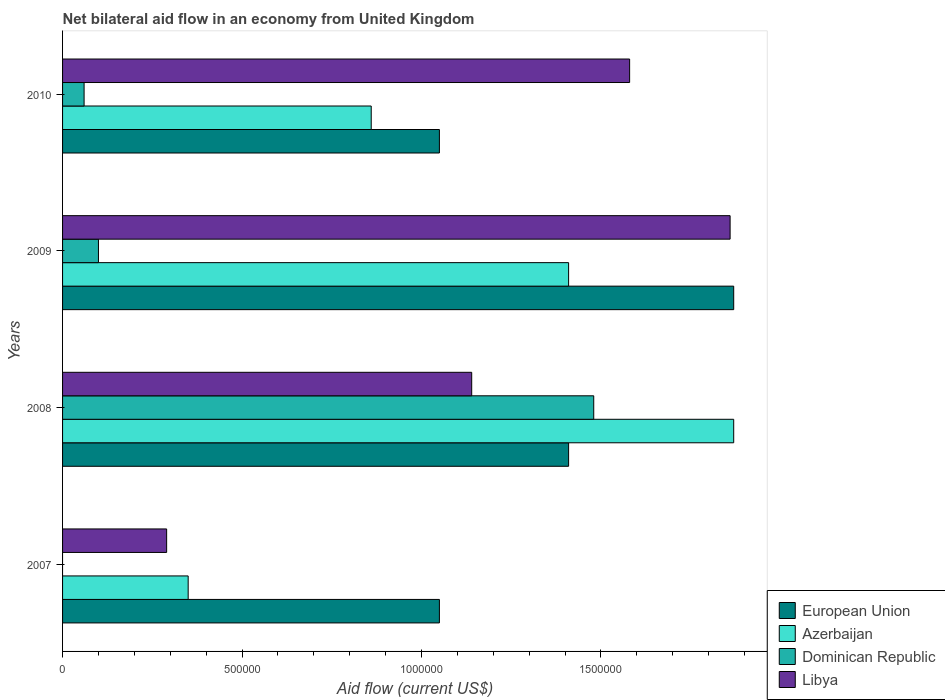How many different coloured bars are there?
Offer a very short reply. 4. Are the number of bars per tick equal to the number of legend labels?
Offer a terse response. No. Are the number of bars on each tick of the Y-axis equal?
Make the answer very short. No. How many bars are there on the 1st tick from the top?
Make the answer very short. 4. In how many cases, is the number of bars for a given year not equal to the number of legend labels?
Keep it short and to the point. 1. What is the net bilateral aid flow in European Union in 2008?
Make the answer very short. 1.41e+06. Across all years, what is the maximum net bilateral aid flow in Azerbaijan?
Keep it short and to the point. 1.87e+06. Across all years, what is the minimum net bilateral aid flow in European Union?
Offer a terse response. 1.05e+06. What is the total net bilateral aid flow in Dominican Republic in the graph?
Your answer should be very brief. 1.64e+06. What is the difference between the net bilateral aid flow in Azerbaijan in 2007 and that in 2010?
Keep it short and to the point. -5.10e+05. What is the difference between the net bilateral aid flow in European Union in 2010 and the net bilateral aid flow in Azerbaijan in 2008?
Your answer should be very brief. -8.20e+05. What is the average net bilateral aid flow in Dominican Republic per year?
Your answer should be compact. 4.10e+05. In the year 2009, what is the difference between the net bilateral aid flow in Libya and net bilateral aid flow in Azerbaijan?
Offer a very short reply. 4.50e+05. What is the ratio of the net bilateral aid flow in Azerbaijan in 2009 to that in 2010?
Your answer should be compact. 1.64. What is the difference between the highest and the lowest net bilateral aid flow in Dominican Republic?
Your answer should be very brief. 1.48e+06. In how many years, is the net bilateral aid flow in European Union greater than the average net bilateral aid flow in European Union taken over all years?
Provide a short and direct response. 2. Is it the case that in every year, the sum of the net bilateral aid flow in Azerbaijan and net bilateral aid flow in European Union is greater than the sum of net bilateral aid flow in Dominican Republic and net bilateral aid flow in Libya?
Your answer should be compact. No. Is it the case that in every year, the sum of the net bilateral aid flow in European Union and net bilateral aid flow in Dominican Republic is greater than the net bilateral aid flow in Azerbaijan?
Your response must be concise. Yes. How many legend labels are there?
Your answer should be very brief. 4. How are the legend labels stacked?
Ensure brevity in your answer.  Vertical. What is the title of the graph?
Provide a succinct answer. Net bilateral aid flow in an economy from United Kingdom. What is the label or title of the X-axis?
Offer a very short reply. Aid flow (current US$). What is the label or title of the Y-axis?
Your response must be concise. Years. What is the Aid flow (current US$) of European Union in 2007?
Keep it short and to the point. 1.05e+06. What is the Aid flow (current US$) of Azerbaijan in 2007?
Give a very brief answer. 3.50e+05. What is the Aid flow (current US$) of European Union in 2008?
Keep it short and to the point. 1.41e+06. What is the Aid flow (current US$) of Azerbaijan in 2008?
Provide a succinct answer. 1.87e+06. What is the Aid flow (current US$) in Dominican Republic in 2008?
Your answer should be compact. 1.48e+06. What is the Aid flow (current US$) in Libya in 2008?
Provide a succinct answer. 1.14e+06. What is the Aid flow (current US$) of European Union in 2009?
Ensure brevity in your answer.  1.87e+06. What is the Aid flow (current US$) in Azerbaijan in 2009?
Keep it short and to the point. 1.41e+06. What is the Aid flow (current US$) of Dominican Republic in 2009?
Provide a short and direct response. 1.00e+05. What is the Aid flow (current US$) in Libya in 2009?
Ensure brevity in your answer.  1.86e+06. What is the Aid flow (current US$) of European Union in 2010?
Offer a terse response. 1.05e+06. What is the Aid flow (current US$) in Azerbaijan in 2010?
Provide a succinct answer. 8.60e+05. What is the Aid flow (current US$) of Libya in 2010?
Provide a short and direct response. 1.58e+06. Across all years, what is the maximum Aid flow (current US$) in European Union?
Offer a very short reply. 1.87e+06. Across all years, what is the maximum Aid flow (current US$) of Azerbaijan?
Provide a succinct answer. 1.87e+06. Across all years, what is the maximum Aid flow (current US$) in Dominican Republic?
Make the answer very short. 1.48e+06. Across all years, what is the maximum Aid flow (current US$) of Libya?
Make the answer very short. 1.86e+06. Across all years, what is the minimum Aid flow (current US$) of European Union?
Ensure brevity in your answer.  1.05e+06. Across all years, what is the minimum Aid flow (current US$) in Azerbaijan?
Your answer should be compact. 3.50e+05. Across all years, what is the minimum Aid flow (current US$) in Dominican Republic?
Make the answer very short. 0. What is the total Aid flow (current US$) of European Union in the graph?
Your answer should be very brief. 5.38e+06. What is the total Aid flow (current US$) of Azerbaijan in the graph?
Ensure brevity in your answer.  4.49e+06. What is the total Aid flow (current US$) in Dominican Republic in the graph?
Offer a terse response. 1.64e+06. What is the total Aid flow (current US$) in Libya in the graph?
Ensure brevity in your answer.  4.87e+06. What is the difference between the Aid flow (current US$) in European Union in 2007 and that in 2008?
Your answer should be compact. -3.60e+05. What is the difference between the Aid flow (current US$) of Azerbaijan in 2007 and that in 2008?
Provide a short and direct response. -1.52e+06. What is the difference between the Aid flow (current US$) in Libya in 2007 and that in 2008?
Offer a very short reply. -8.50e+05. What is the difference between the Aid flow (current US$) of European Union in 2007 and that in 2009?
Your response must be concise. -8.20e+05. What is the difference between the Aid flow (current US$) in Azerbaijan in 2007 and that in 2009?
Your answer should be compact. -1.06e+06. What is the difference between the Aid flow (current US$) in Libya in 2007 and that in 2009?
Offer a very short reply. -1.57e+06. What is the difference between the Aid flow (current US$) in European Union in 2007 and that in 2010?
Your answer should be very brief. 0. What is the difference between the Aid flow (current US$) in Azerbaijan in 2007 and that in 2010?
Your answer should be compact. -5.10e+05. What is the difference between the Aid flow (current US$) of Libya in 2007 and that in 2010?
Provide a succinct answer. -1.29e+06. What is the difference between the Aid flow (current US$) in European Union in 2008 and that in 2009?
Provide a succinct answer. -4.60e+05. What is the difference between the Aid flow (current US$) of Azerbaijan in 2008 and that in 2009?
Offer a very short reply. 4.60e+05. What is the difference between the Aid flow (current US$) in Dominican Republic in 2008 and that in 2009?
Your response must be concise. 1.38e+06. What is the difference between the Aid flow (current US$) in Libya in 2008 and that in 2009?
Your answer should be compact. -7.20e+05. What is the difference between the Aid flow (current US$) in European Union in 2008 and that in 2010?
Make the answer very short. 3.60e+05. What is the difference between the Aid flow (current US$) of Azerbaijan in 2008 and that in 2010?
Your response must be concise. 1.01e+06. What is the difference between the Aid flow (current US$) in Dominican Republic in 2008 and that in 2010?
Offer a very short reply. 1.42e+06. What is the difference between the Aid flow (current US$) in Libya in 2008 and that in 2010?
Offer a terse response. -4.40e+05. What is the difference between the Aid flow (current US$) in European Union in 2009 and that in 2010?
Provide a succinct answer. 8.20e+05. What is the difference between the Aid flow (current US$) of Azerbaijan in 2009 and that in 2010?
Provide a short and direct response. 5.50e+05. What is the difference between the Aid flow (current US$) of Dominican Republic in 2009 and that in 2010?
Your response must be concise. 4.00e+04. What is the difference between the Aid flow (current US$) of European Union in 2007 and the Aid flow (current US$) of Azerbaijan in 2008?
Offer a terse response. -8.20e+05. What is the difference between the Aid flow (current US$) of European Union in 2007 and the Aid flow (current US$) of Dominican Republic in 2008?
Your answer should be compact. -4.30e+05. What is the difference between the Aid flow (current US$) of Azerbaijan in 2007 and the Aid flow (current US$) of Dominican Republic in 2008?
Your answer should be very brief. -1.13e+06. What is the difference between the Aid flow (current US$) in Azerbaijan in 2007 and the Aid flow (current US$) in Libya in 2008?
Your answer should be compact. -7.90e+05. What is the difference between the Aid flow (current US$) of European Union in 2007 and the Aid flow (current US$) of Azerbaijan in 2009?
Your answer should be compact. -3.60e+05. What is the difference between the Aid flow (current US$) in European Union in 2007 and the Aid flow (current US$) in Dominican Republic in 2009?
Make the answer very short. 9.50e+05. What is the difference between the Aid flow (current US$) of European Union in 2007 and the Aid flow (current US$) of Libya in 2009?
Give a very brief answer. -8.10e+05. What is the difference between the Aid flow (current US$) of Azerbaijan in 2007 and the Aid flow (current US$) of Libya in 2009?
Provide a succinct answer. -1.51e+06. What is the difference between the Aid flow (current US$) of European Union in 2007 and the Aid flow (current US$) of Azerbaijan in 2010?
Give a very brief answer. 1.90e+05. What is the difference between the Aid flow (current US$) in European Union in 2007 and the Aid flow (current US$) in Dominican Republic in 2010?
Your response must be concise. 9.90e+05. What is the difference between the Aid flow (current US$) in European Union in 2007 and the Aid flow (current US$) in Libya in 2010?
Make the answer very short. -5.30e+05. What is the difference between the Aid flow (current US$) of Azerbaijan in 2007 and the Aid flow (current US$) of Dominican Republic in 2010?
Your response must be concise. 2.90e+05. What is the difference between the Aid flow (current US$) of Azerbaijan in 2007 and the Aid flow (current US$) of Libya in 2010?
Give a very brief answer. -1.23e+06. What is the difference between the Aid flow (current US$) of European Union in 2008 and the Aid flow (current US$) of Azerbaijan in 2009?
Ensure brevity in your answer.  0. What is the difference between the Aid flow (current US$) in European Union in 2008 and the Aid flow (current US$) in Dominican Republic in 2009?
Offer a terse response. 1.31e+06. What is the difference between the Aid flow (current US$) in European Union in 2008 and the Aid flow (current US$) in Libya in 2009?
Offer a terse response. -4.50e+05. What is the difference between the Aid flow (current US$) of Azerbaijan in 2008 and the Aid flow (current US$) of Dominican Republic in 2009?
Make the answer very short. 1.77e+06. What is the difference between the Aid flow (current US$) of Azerbaijan in 2008 and the Aid flow (current US$) of Libya in 2009?
Offer a very short reply. 10000. What is the difference between the Aid flow (current US$) of Dominican Republic in 2008 and the Aid flow (current US$) of Libya in 2009?
Offer a very short reply. -3.80e+05. What is the difference between the Aid flow (current US$) in European Union in 2008 and the Aid flow (current US$) in Azerbaijan in 2010?
Offer a terse response. 5.50e+05. What is the difference between the Aid flow (current US$) in European Union in 2008 and the Aid flow (current US$) in Dominican Republic in 2010?
Give a very brief answer. 1.35e+06. What is the difference between the Aid flow (current US$) in European Union in 2008 and the Aid flow (current US$) in Libya in 2010?
Make the answer very short. -1.70e+05. What is the difference between the Aid flow (current US$) in Azerbaijan in 2008 and the Aid flow (current US$) in Dominican Republic in 2010?
Give a very brief answer. 1.81e+06. What is the difference between the Aid flow (current US$) in Dominican Republic in 2008 and the Aid flow (current US$) in Libya in 2010?
Keep it short and to the point. -1.00e+05. What is the difference between the Aid flow (current US$) of European Union in 2009 and the Aid flow (current US$) of Azerbaijan in 2010?
Provide a short and direct response. 1.01e+06. What is the difference between the Aid flow (current US$) in European Union in 2009 and the Aid flow (current US$) in Dominican Republic in 2010?
Offer a terse response. 1.81e+06. What is the difference between the Aid flow (current US$) of Azerbaijan in 2009 and the Aid flow (current US$) of Dominican Republic in 2010?
Your response must be concise. 1.35e+06. What is the difference between the Aid flow (current US$) in Azerbaijan in 2009 and the Aid flow (current US$) in Libya in 2010?
Ensure brevity in your answer.  -1.70e+05. What is the difference between the Aid flow (current US$) of Dominican Republic in 2009 and the Aid flow (current US$) of Libya in 2010?
Provide a succinct answer. -1.48e+06. What is the average Aid flow (current US$) of European Union per year?
Your answer should be compact. 1.34e+06. What is the average Aid flow (current US$) in Azerbaijan per year?
Give a very brief answer. 1.12e+06. What is the average Aid flow (current US$) of Libya per year?
Provide a succinct answer. 1.22e+06. In the year 2007, what is the difference between the Aid flow (current US$) in European Union and Aid flow (current US$) in Libya?
Your answer should be compact. 7.60e+05. In the year 2007, what is the difference between the Aid flow (current US$) in Azerbaijan and Aid flow (current US$) in Libya?
Provide a short and direct response. 6.00e+04. In the year 2008, what is the difference between the Aid flow (current US$) in European Union and Aid flow (current US$) in Azerbaijan?
Provide a short and direct response. -4.60e+05. In the year 2008, what is the difference between the Aid flow (current US$) of Azerbaijan and Aid flow (current US$) of Libya?
Your response must be concise. 7.30e+05. In the year 2009, what is the difference between the Aid flow (current US$) in European Union and Aid flow (current US$) in Dominican Republic?
Make the answer very short. 1.77e+06. In the year 2009, what is the difference between the Aid flow (current US$) of European Union and Aid flow (current US$) of Libya?
Give a very brief answer. 10000. In the year 2009, what is the difference between the Aid flow (current US$) of Azerbaijan and Aid flow (current US$) of Dominican Republic?
Give a very brief answer. 1.31e+06. In the year 2009, what is the difference between the Aid flow (current US$) of Azerbaijan and Aid flow (current US$) of Libya?
Offer a very short reply. -4.50e+05. In the year 2009, what is the difference between the Aid flow (current US$) in Dominican Republic and Aid flow (current US$) in Libya?
Your response must be concise. -1.76e+06. In the year 2010, what is the difference between the Aid flow (current US$) of European Union and Aid flow (current US$) of Azerbaijan?
Ensure brevity in your answer.  1.90e+05. In the year 2010, what is the difference between the Aid flow (current US$) in European Union and Aid flow (current US$) in Dominican Republic?
Your answer should be compact. 9.90e+05. In the year 2010, what is the difference between the Aid flow (current US$) in European Union and Aid flow (current US$) in Libya?
Offer a very short reply. -5.30e+05. In the year 2010, what is the difference between the Aid flow (current US$) in Azerbaijan and Aid flow (current US$) in Dominican Republic?
Ensure brevity in your answer.  8.00e+05. In the year 2010, what is the difference between the Aid flow (current US$) in Azerbaijan and Aid flow (current US$) in Libya?
Offer a very short reply. -7.20e+05. In the year 2010, what is the difference between the Aid flow (current US$) of Dominican Republic and Aid flow (current US$) of Libya?
Your answer should be compact. -1.52e+06. What is the ratio of the Aid flow (current US$) of European Union in 2007 to that in 2008?
Give a very brief answer. 0.74. What is the ratio of the Aid flow (current US$) of Azerbaijan in 2007 to that in 2008?
Offer a terse response. 0.19. What is the ratio of the Aid flow (current US$) in Libya in 2007 to that in 2008?
Your response must be concise. 0.25. What is the ratio of the Aid flow (current US$) in European Union in 2007 to that in 2009?
Give a very brief answer. 0.56. What is the ratio of the Aid flow (current US$) of Azerbaijan in 2007 to that in 2009?
Ensure brevity in your answer.  0.25. What is the ratio of the Aid flow (current US$) in Libya in 2007 to that in 2009?
Provide a succinct answer. 0.16. What is the ratio of the Aid flow (current US$) of Azerbaijan in 2007 to that in 2010?
Keep it short and to the point. 0.41. What is the ratio of the Aid flow (current US$) of Libya in 2007 to that in 2010?
Provide a succinct answer. 0.18. What is the ratio of the Aid flow (current US$) of European Union in 2008 to that in 2009?
Your answer should be compact. 0.75. What is the ratio of the Aid flow (current US$) of Azerbaijan in 2008 to that in 2009?
Keep it short and to the point. 1.33. What is the ratio of the Aid flow (current US$) in Libya in 2008 to that in 2009?
Make the answer very short. 0.61. What is the ratio of the Aid flow (current US$) in European Union in 2008 to that in 2010?
Make the answer very short. 1.34. What is the ratio of the Aid flow (current US$) in Azerbaijan in 2008 to that in 2010?
Keep it short and to the point. 2.17. What is the ratio of the Aid flow (current US$) of Dominican Republic in 2008 to that in 2010?
Provide a succinct answer. 24.67. What is the ratio of the Aid flow (current US$) in Libya in 2008 to that in 2010?
Ensure brevity in your answer.  0.72. What is the ratio of the Aid flow (current US$) of European Union in 2009 to that in 2010?
Ensure brevity in your answer.  1.78. What is the ratio of the Aid flow (current US$) in Azerbaijan in 2009 to that in 2010?
Give a very brief answer. 1.64. What is the ratio of the Aid flow (current US$) in Libya in 2009 to that in 2010?
Keep it short and to the point. 1.18. What is the difference between the highest and the second highest Aid flow (current US$) in European Union?
Offer a terse response. 4.60e+05. What is the difference between the highest and the second highest Aid flow (current US$) in Dominican Republic?
Keep it short and to the point. 1.38e+06. What is the difference between the highest and the lowest Aid flow (current US$) in European Union?
Offer a very short reply. 8.20e+05. What is the difference between the highest and the lowest Aid flow (current US$) of Azerbaijan?
Make the answer very short. 1.52e+06. What is the difference between the highest and the lowest Aid flow (current US$) in Dominican Republic?
Your answer should be compact. 1.48e+06. What is the difference between the highest and the lowest Aid flow (current US$) in Libya?
Provide a succinct answer. 1.57e+06. 